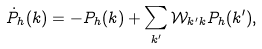<formula> <loc_0><loc_0><loc_500><loc_500>\dot { P } _ { h } ( k ) = - P _ { h } ( k ) + \sum _ { k ^ { \prime } } \mathcal { W } _ { k ^ { \prime } k } P _ { h } ( k ^ { \prime } ) ,</formula> 